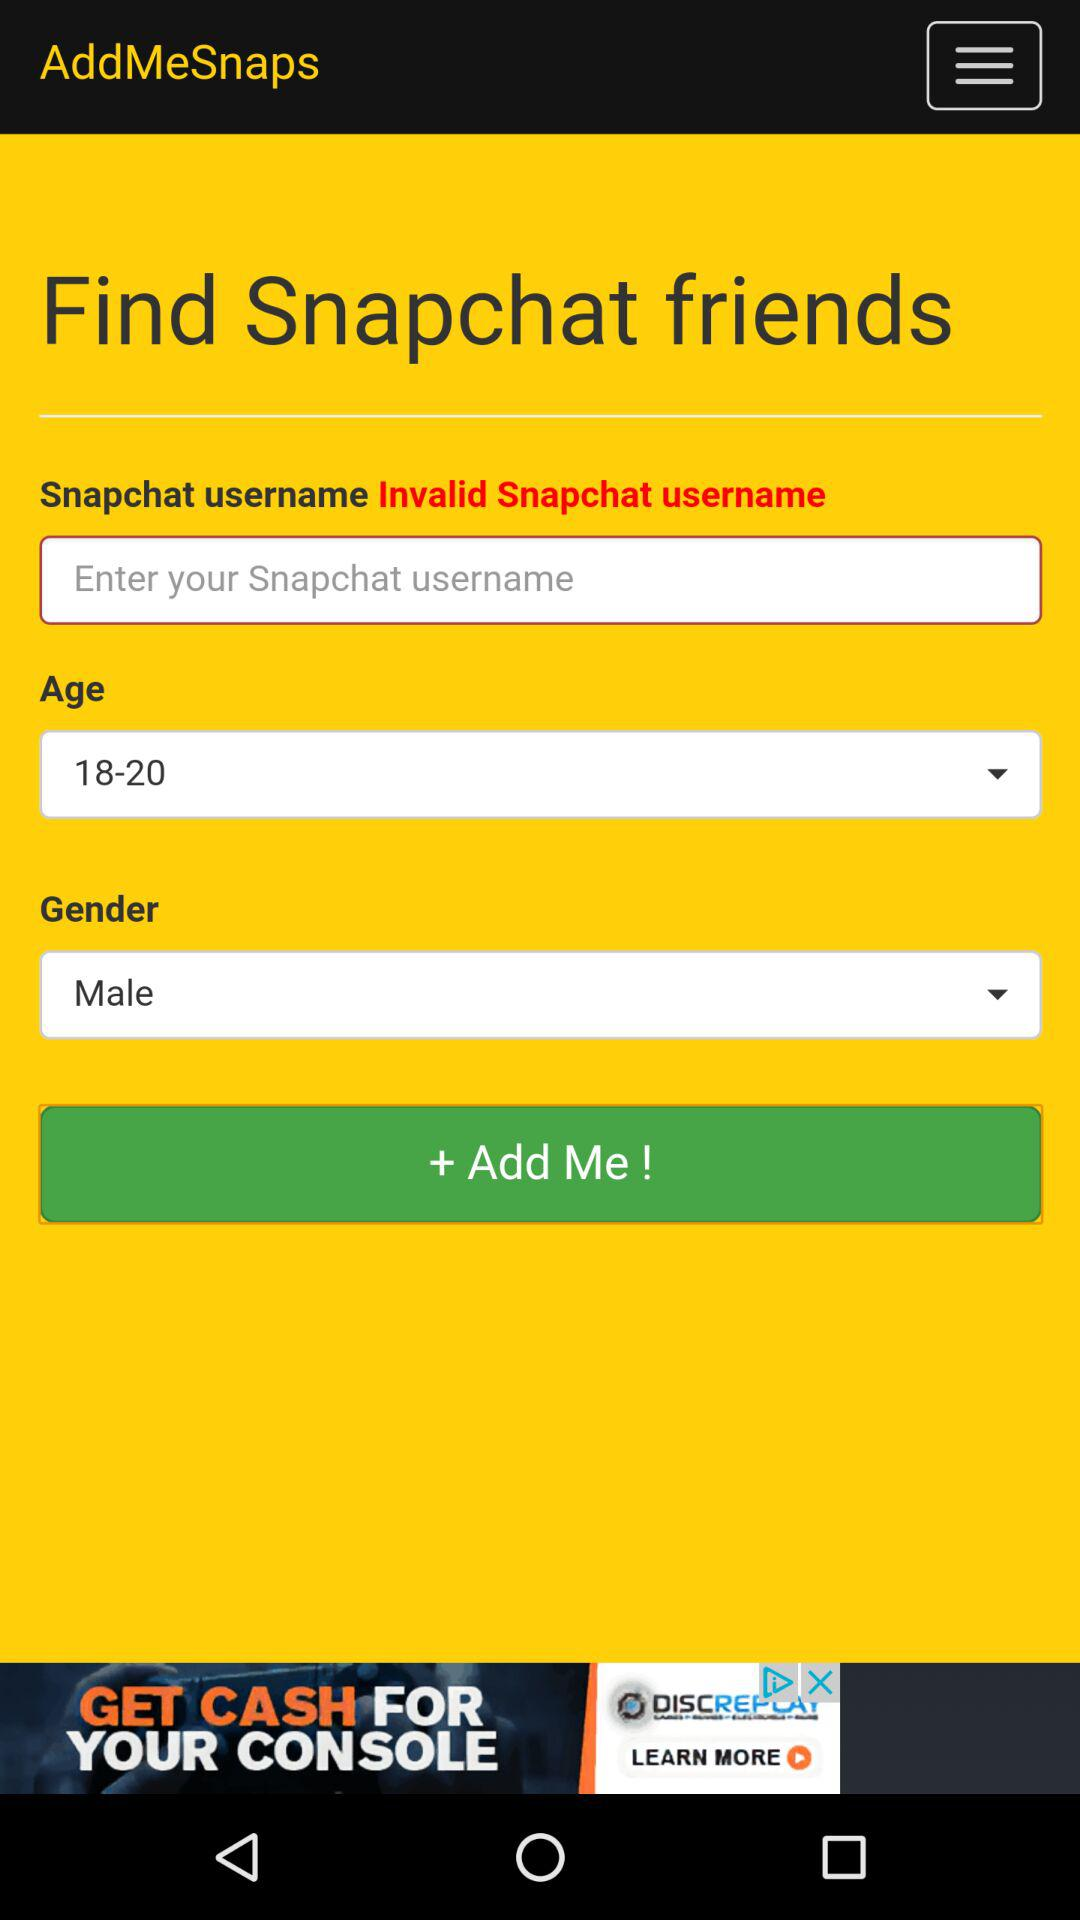What is the selected gender? The selected gender is male. 